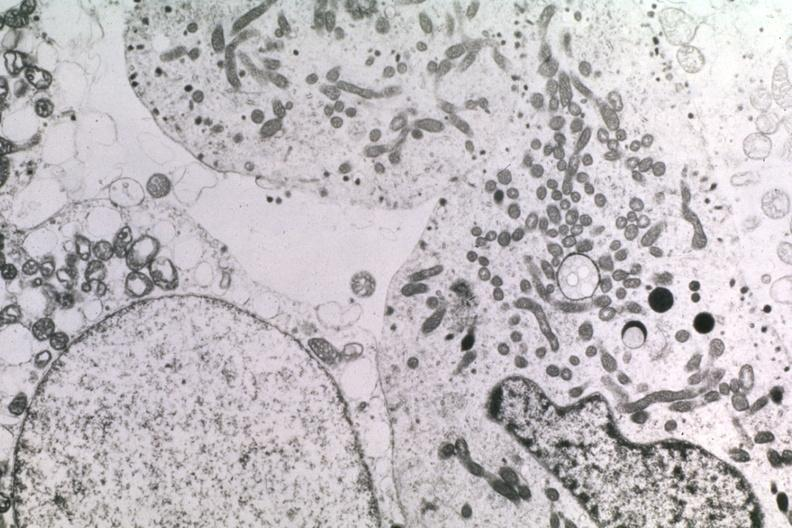does this image show null cell dr garcia tumors 35?
Answer the question using a single word or phrase. Yes 